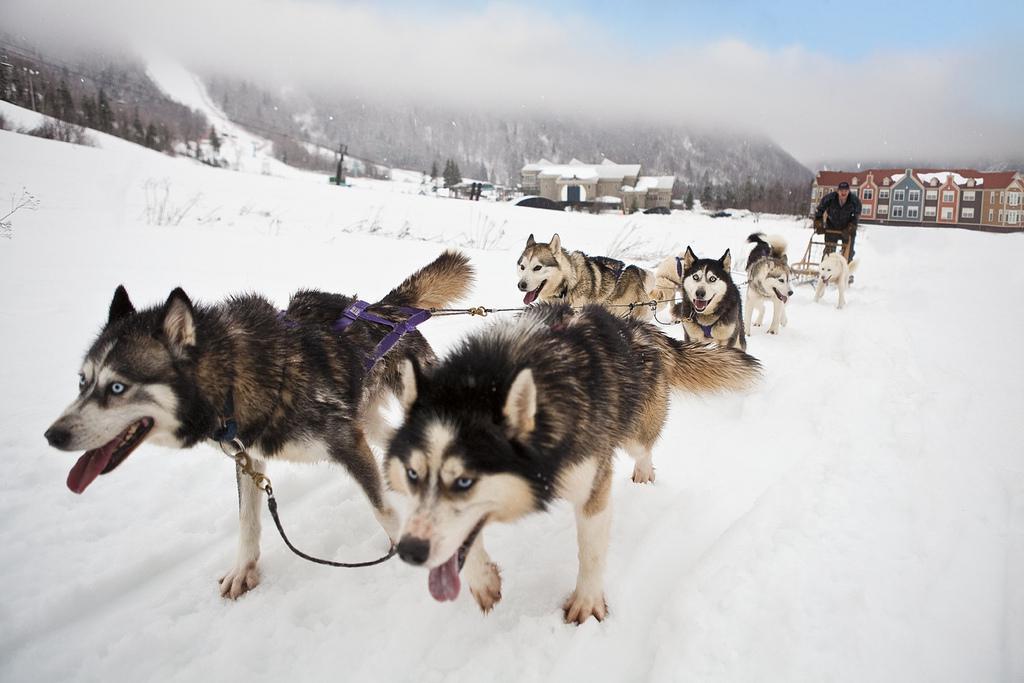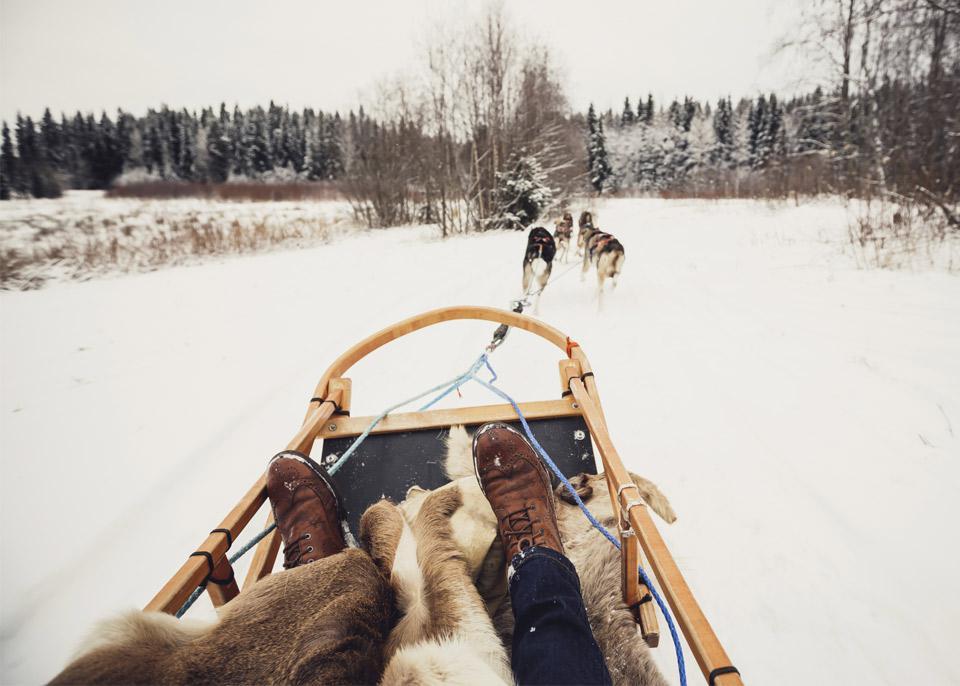The first image is the image on the left, the second image is the image on the right. Examine the images to the left and right. Is the description "All the dogs are moving forward." accurate? Answer yes or no. Yes. The first image is the image on the left, the second image is the image on the right. Analyze the images presented: Is the assertion "in one of the images, a dogsled is headed towards the right." valid? Answer yes or no. No. 